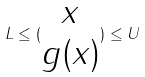Convert formula to latex. <formula><loc_0><loc_0><loc_500><loc_500>L \leq ( \begin{matrix} x \\ g ( x ) \end{matrix} ) \leq U</formula> 